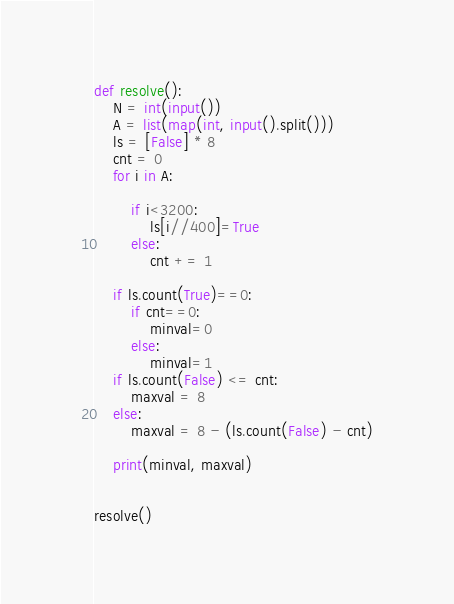<code> <loc_0><loc_0><loc_500><loc_500><_Python_>def resolve():
    N = int(input())
    A = list(map(int, input().split()))
    ls = [False] * 8
    cnt = 0
    for i in A:

        if i<3200:
            ls[i//400]=True
        else:
            cnt += 1

    if ls.count(True)==0:
        if cnt==0:
            minval=0
        else:
            minval=1
    if ls.count(False) <= cnt:
        maxval = 8
    else:
        maxval = 8 - (ls.count(False) - cnt)

    print(minval, maxval)


resolve()</code> 